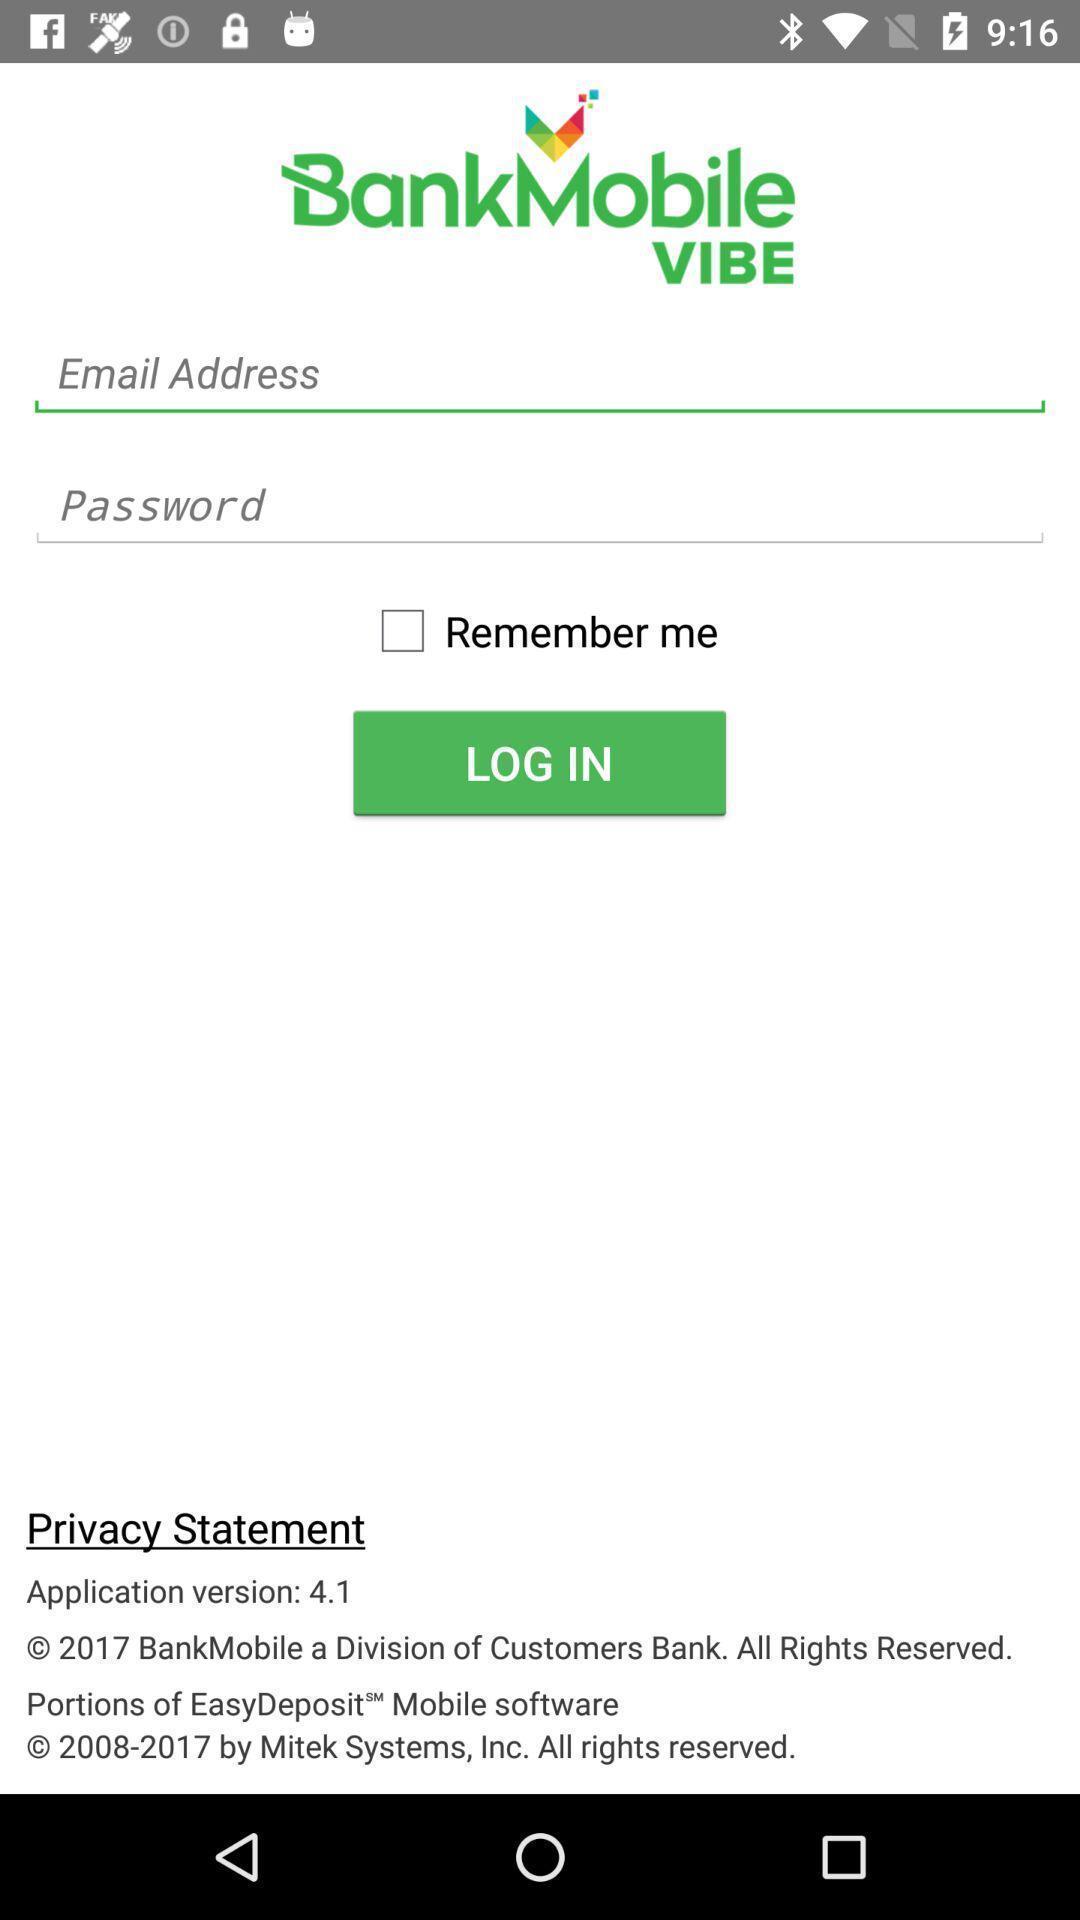What details can you identify in this image? Page requesting to enter login credentials on an app. 